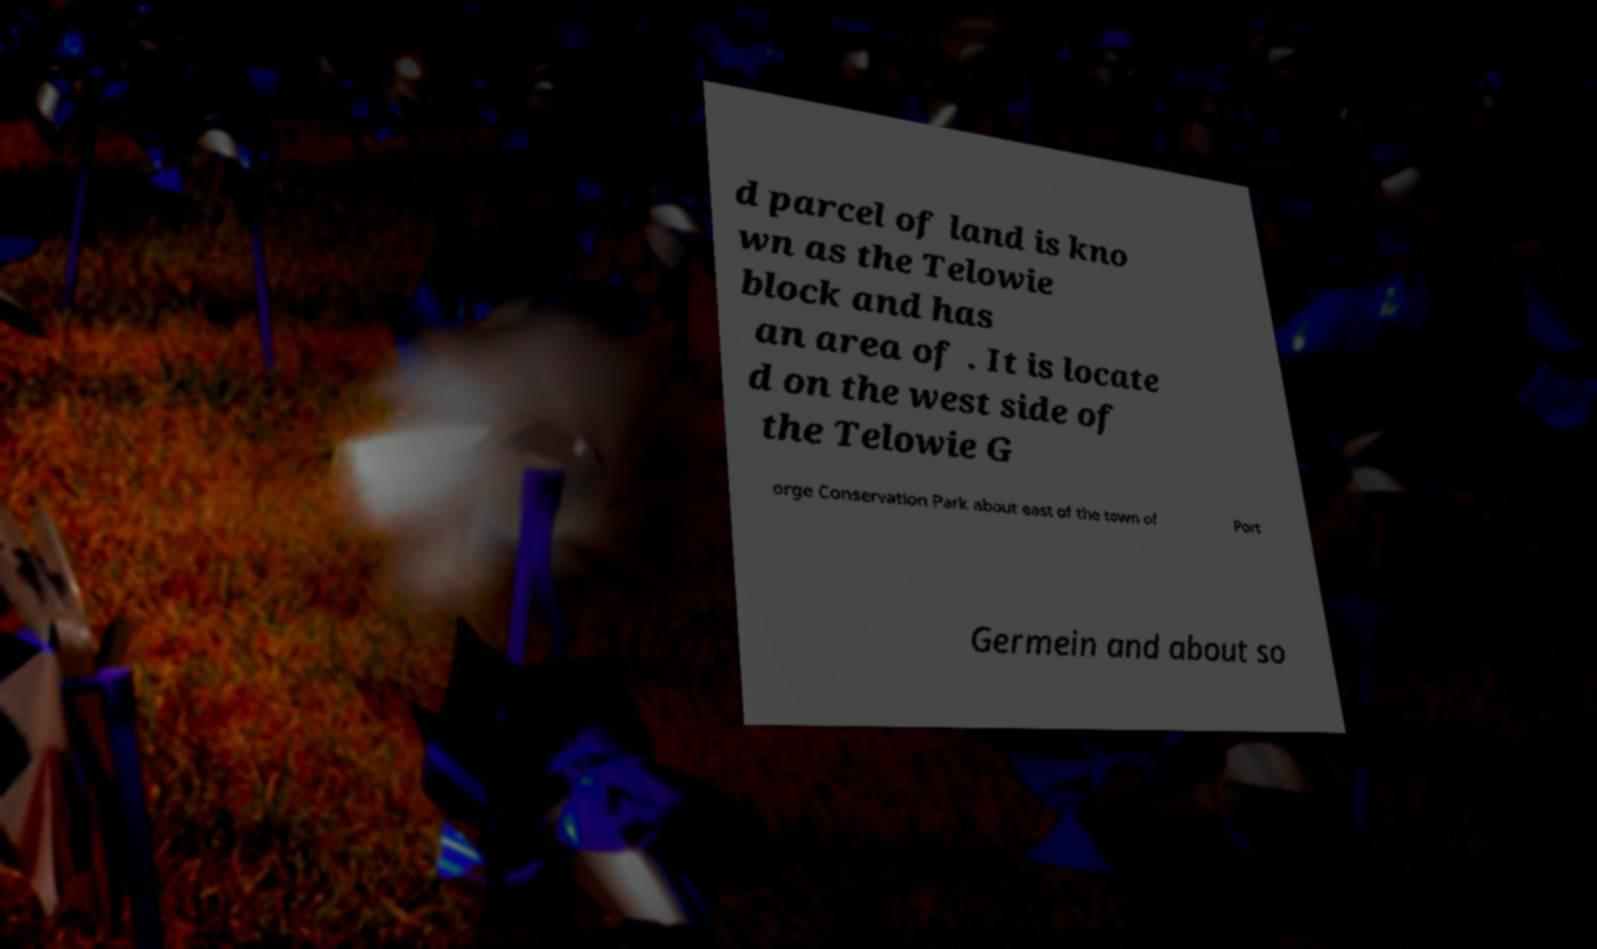Please read and relay the text visible in this image. What does it say? d parcel of land is kno wn as the Telowie block and has an area of . It is locate d on the west side of the Telowie G orge Conservation Park about east of the town of Port Germein and about so 